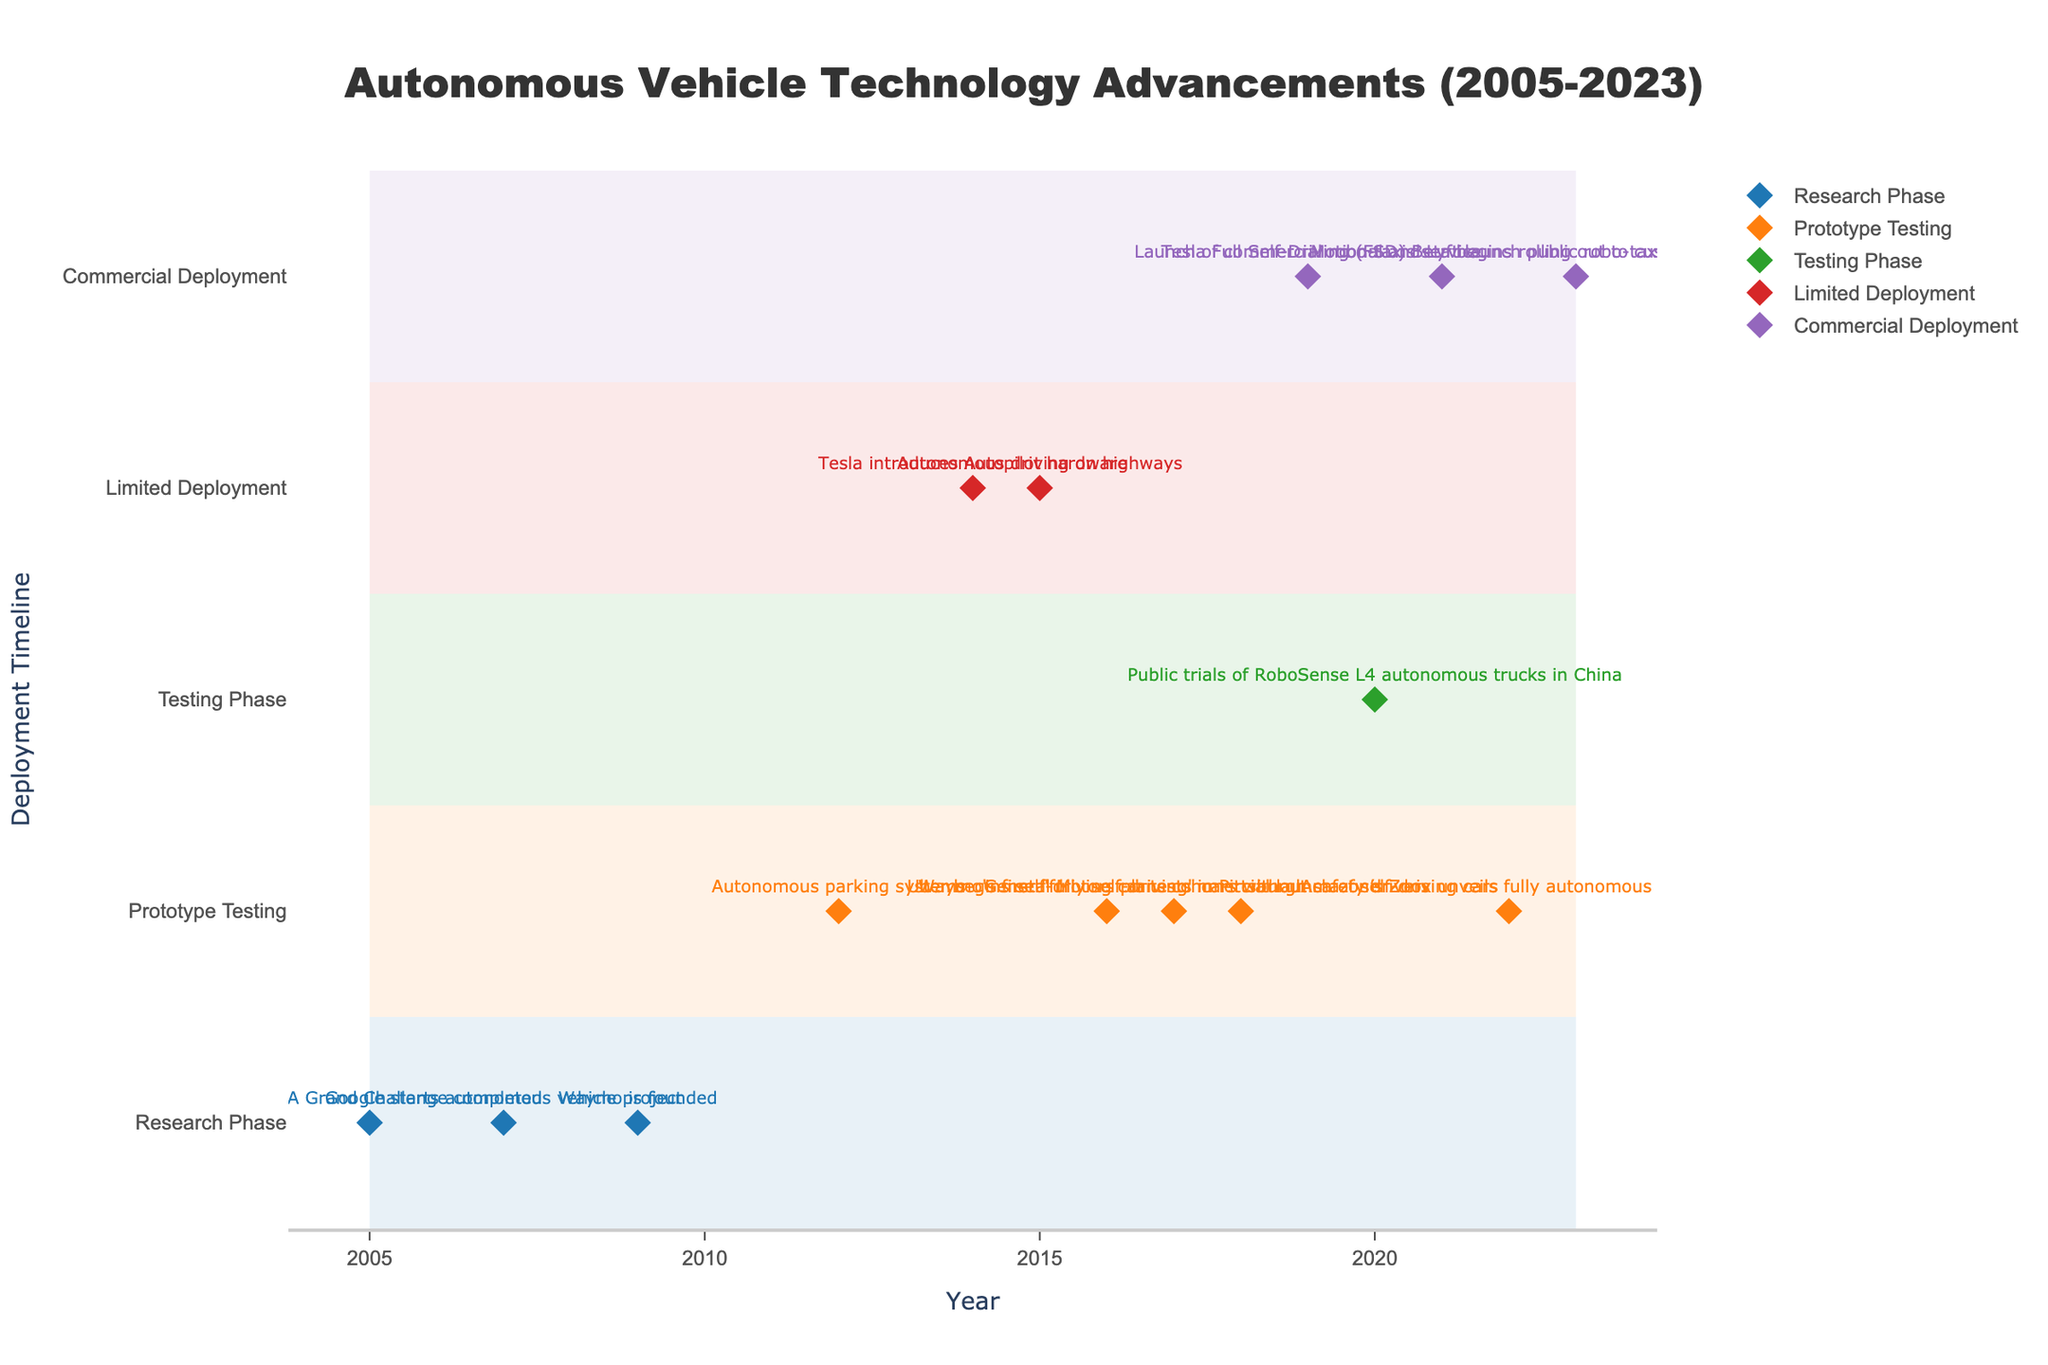What is the title of the figure? The title is displayed at the top center of the figure.
Answer: Autonomous Vehicle Technology Advancements (2005-2023) How many deployment timelines are depicted in the figure? By counting the distinct deployment timelines in the y-axis, the figure shows five categories.
Answer: 5 Which company first initiated the autonomous vehicle project according to the figure? Follow the timeline from 2005 onwards and identify the first instance of an autonomous vehicle project on the x-axis.
Answer: Google Research When did Tesla start its Full Self-Driving (FSD) Beta roll-out to customers? Locate Tesla events on the x-axis and look at the year associated with Full Self-Driving (FSD) Beta.
Answer: 2021 Which milestone technology is associated with the "Commercial Deployment" in 2019? Find the year 2019 on the x-axis, then see which technology is indicated on the "Commercial Deployment" timeline.
Answer: Launch of commercial robo-taxis service How many technologies were in the "Prototype Testing" phase in 2017? Look at the "Prototype Testing" deployment timeline on the y-axis for the year 2017, and count the technologies listed.
Answer: 1 Which company launched a public robo-taxi service in Las Vegas, and in which year? Refer to the hover info for entries under "Commercial Deployment" and find the one associated with "public robo-taxi service in Las Vegas."
Answer: Motional in 2023 Compare the number of autonomous vehicle technologies in the "Research Phase" and "Prototype Testing" in 2009. Which phase had more advancements? Identify the number of technologies in each deployment phase for the year 2009, compare the counts.
Answer: Research Phase What are the colors representing the "Limited Deployment" and "Commercial Deployment" phases? Observe the legend for the colors used to denote "Limited Deployment" and "Commercial Deployment."
Answer: Red and Purple respectively How many years after Google started its autonomous vehicle project did Waymo launch a commercial robo-taxis service? Subtract the starting year of Google's project from the year of Waymo's commercial robo-taxis launch to find the difference. 2019 - 2007 = 12 years
Answer: 12 years 